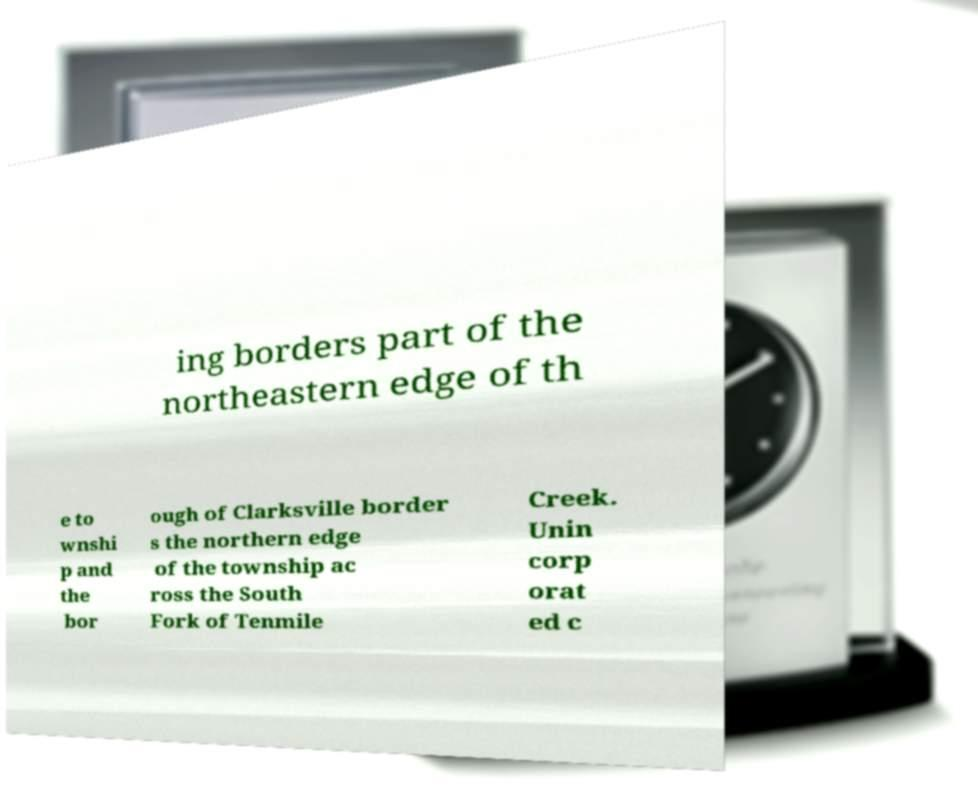Could you extract and type out the text from this image? ing borders part of the northeastern edge of th e to wnshi p and the bor ough of Clarksville border s the northern edge of the township ac ross the South Fork of Tenmile Creek. Unin corp orat ed c 